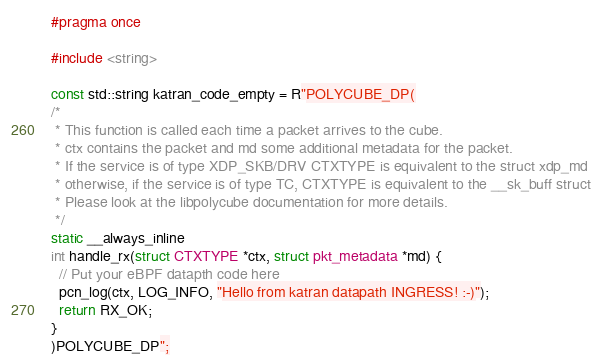Convert code to text. <code><loc_0><loc_0><loc_500><loc_500><_C_>#pragma once

#include <string>

const std::string katran_code_empty = R"POLYCUBE_DP(
/*
 * This function is called each time a packet arrives to the cube.
 * ctx contains the packet and md some additional metadata for the packet.
 * If the service is of type XDP_SKB/DRV CTXTYPE is equivalent to the struct xdp_md
 * otherwise, if the service is of type TC, CTXTYPE is equivalent to the __sk_buff struct
 * Please look at the libpolycube documentation for more details.
 */
static __always_inline
int handle_rx(struct CTXTYPE *ctx, struct pkt_metadata *md) {
  // Put your eBPF datapth code here
  pcn_log(ctx, LOG_INFO, "Hello from katran datapath INGRESS! :-)");
  return RX_OK;
}
)POLYCUBE_DP";</code> 